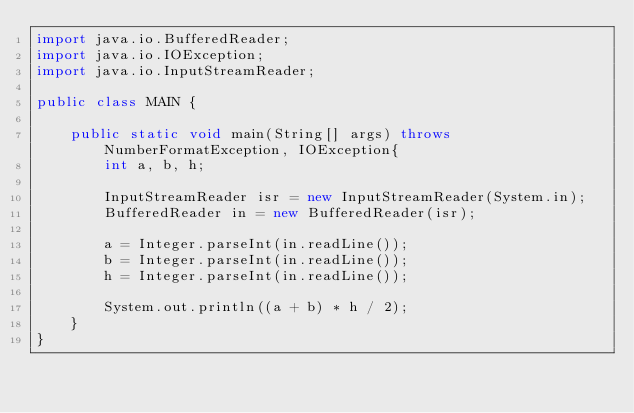Convert code to text. <code><loc_0><loc_0><loc_500><loc_500><_Java_>import java.io.BufferedReader;
import java.io.IOException;
import java.io.InputStreamReader;

public class MAIN {

	public static void main(String[] args) throws NumberFormatException, IOException{
		int a, b, h;

		InputStreamReader isr = new InputStreamReader(System.in);
		BufferedReader in = new BufferedReader(isr);

		a = Integer.parseInt(in.readLine());
		b = Integer.parseInt(in.readLine());
		h = Integer.parseInt(in.readLine());

		System.out.println((a + b) * h / 2);
	}
}
</code> 